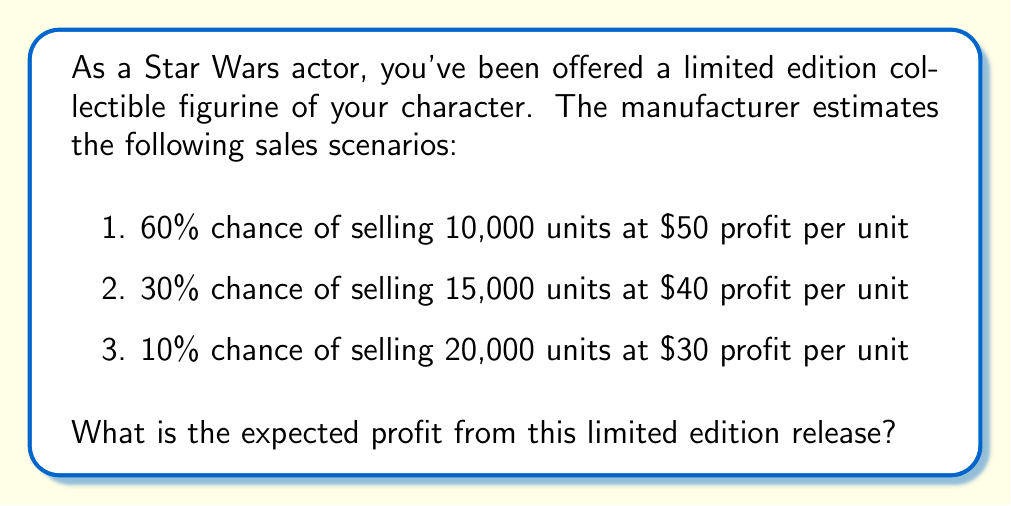Teach me how to tackle this problem. To calculate the expected profit, we need to multiply each possible profit outcome by its probability and then sum these values. Let's break it down step-by-step:

1. For the first scenario:
   Probability: 60% = 0.60
   Profit: 10,000 units × $50/unit = $500,000
   Expected value: $500,000 × 0.60 = $300,000

2. For the second scenario:
   Probability: 30% = 0.30
   Profit: 15,000 units × $40/unit = $600,000
   Expected value: $600,000 × 0.30 = $180,000

3. For the third scenario:
   Probability: 10% = 0.10
   Profit: 20,000 units × $30/unit = $600,000
   Expected value: $600,000 × 0.10 = $60,000

Now, we sum these expected values:

$$ E(\text{Profit}) = 300,000 + 180,000 + 60,000 = 540,000 $$

Therefore, the expected profit from this limited edition release is $540,000.
Answer: $540,000 